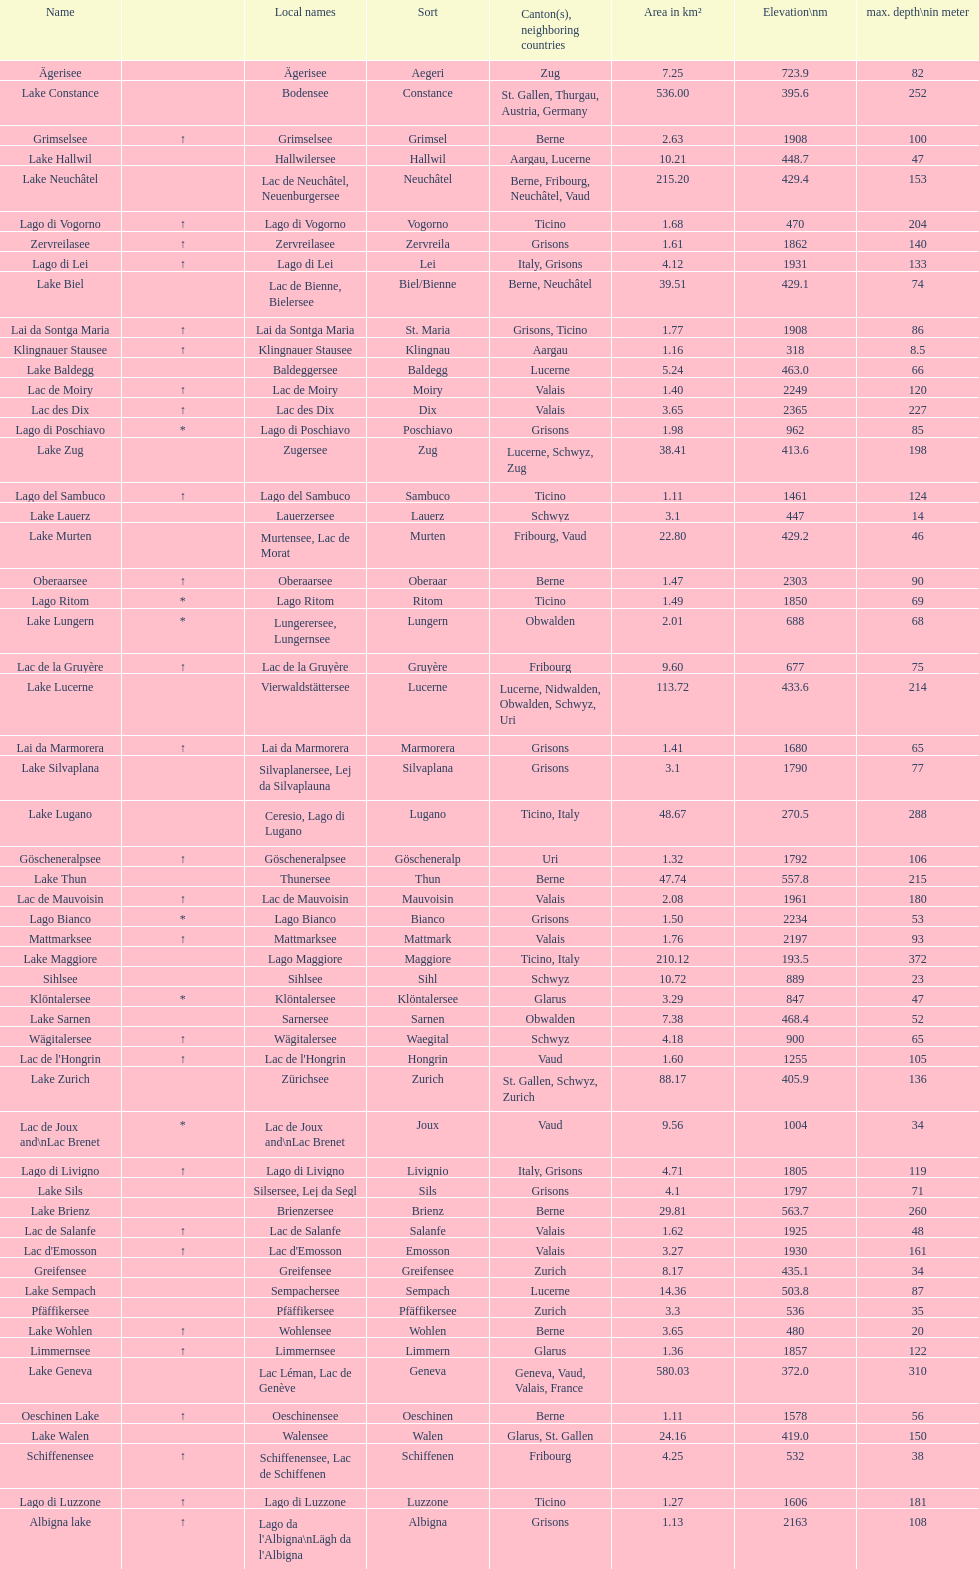Which lake has at least 580 area in km²? Lake Geneva. 